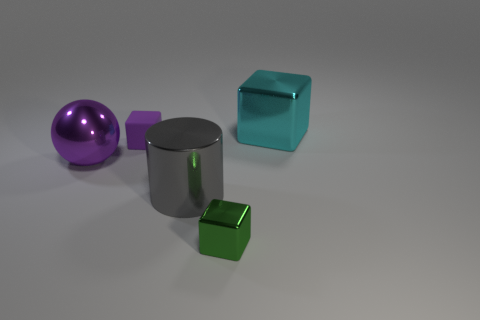What is the material of the purple object that is to the left of the tiny purple block? The purple object appears to exhibit a reflective surface similar to polished metal, suggesting it is likely made of a metal or metal-like material. Its smooth finish and luster are characteristic features of metallic objects. 